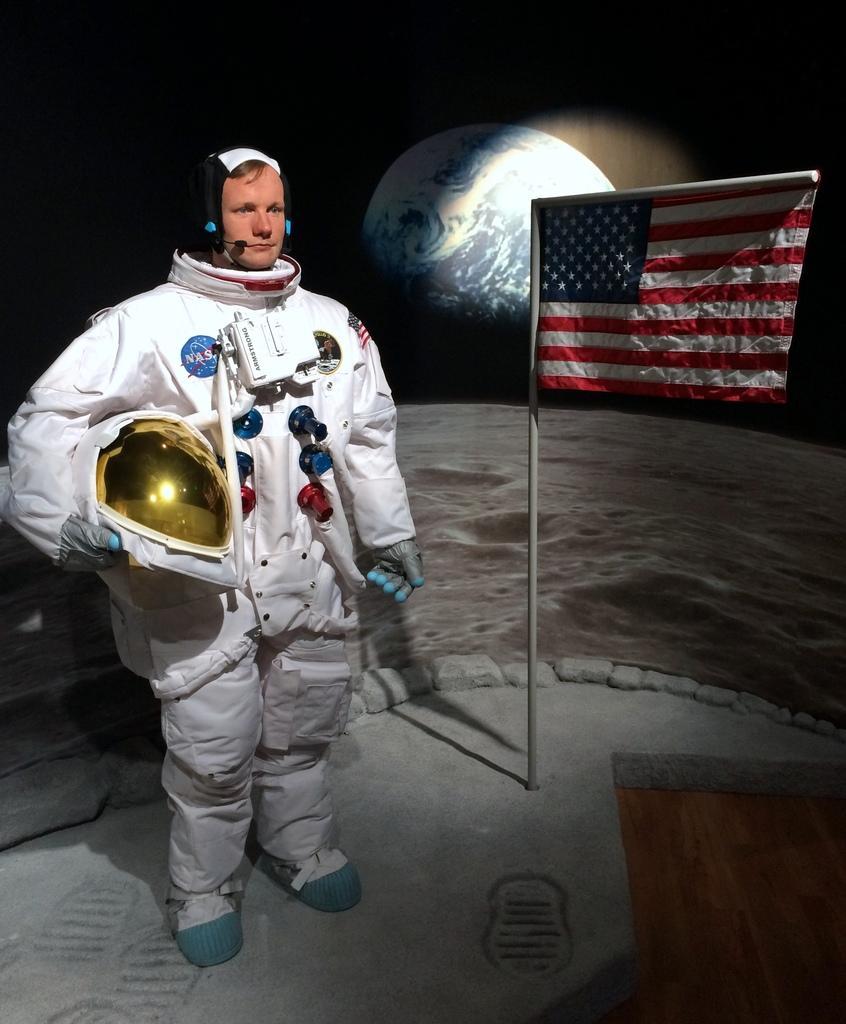Describe this image in one or two sentences. In this image, we can see a person is wearing a space suit and holding a helmet. Beside him, there is a pole with flag. Background there is a dark view. Here we can see an earth. 